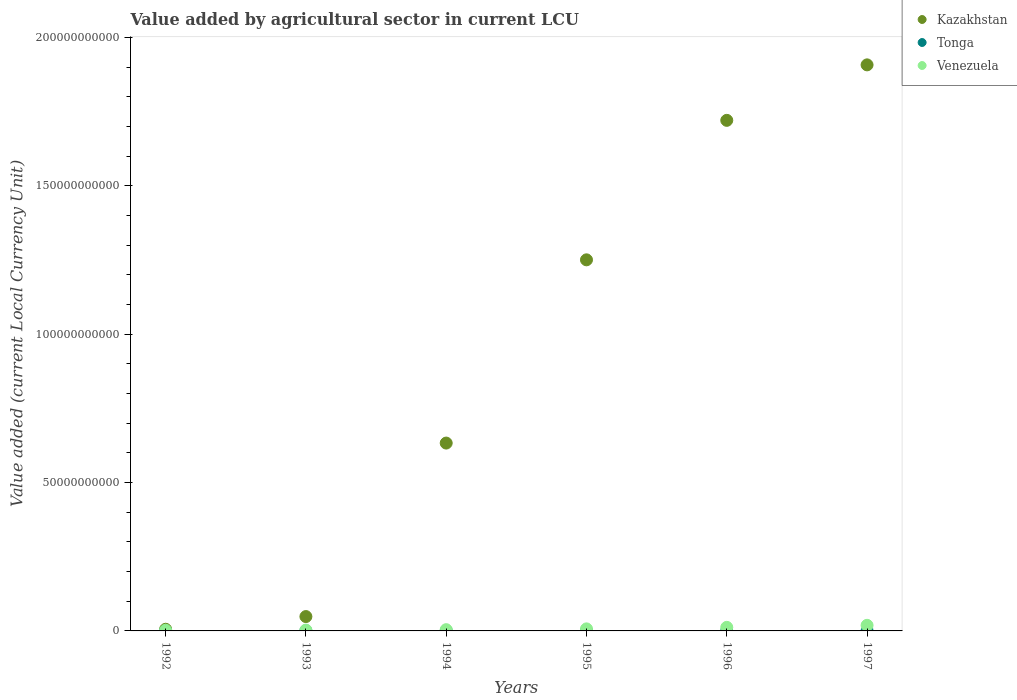How many different coloured dotlines are there?
Keep it short and to the point. 3. What is the value added by agricultural sector in Kazakhstan in 1992?
Your response must be concise. 5.63e+08. Across all years, what is the maximum value added by agricultural sector in Tonga?
Offer a very short reply. 6.54e+07. Across all years, what is the minimum value added by agricultural sector in Venezuela?
Provide a short and direct response. 2.12e+08. In which year was the value added by agricultural sector in Tonga minimum?
Keep it short and to the point. 1997. What is the total value added by agricultural sector in Venezuela in the graph?
Offer a terse response. 4.70e+09. What is the difference between the value added by agricultural sector in Kazakhstan in 1996 and that in 1997?
Make the answer very short. -1.87e+1. What is the difference between the value added by agricultural sector in Kazakhstan in 1993 and the value added by agricultural sector in Venezuela in 1997?
Offer a very short reply. 2.95e+09. What is the average value added by agricultural sector in Venezuela per year?
Provide a succinct answer. 7.83e+08. In the year 1995, what is the difference between the value added by agricultural sector in Tonga and value added by agricultural sector in Kazakhstan?
Make the answer very short. -1.25e+11. In how many years, is the value added by agricultural sector in Tonga greater than 190000000000 LCU?
Your response must be concise. 0. What is the ratio of the value added by agricultural sector in Venezuela in 1992 to that in 1993?
Your response must be concise. 0.75. Is the value added by agricultural sector in Kazakhstan in 1995 less than that in 1996?
Your answer should be very brief. Yes. Is the difference between the value added by agricultural sector in Tonga in 1992 and 1995 greater than the difference between the value added by agricultural sector in Kazakhstan in 1992 and 1995?
Your response must be concise. Yes. What is the difference between the highest and the second highest value added by agricultural sector in Kazakhstan?
Your response must be concise. 1.87e+1. What is the difference between the highest and the lowest value added by agricultural sector in Tonga?
Offer a very short reply. 1.03e+07. Does the value added by agricultural sector in Tonga monotonically increase over the years?
Give a very brief answer. No. Is the value added by agricultural sector in Tonga strictly greater than the value added by agricultural sector in Kazakhstan over the years?
Provide a short and direct response. No. Is the value added by agricultural sector in Venezuela strictly less than the value added by agricultural sector in Kazakhstan over the years?
Your answer should be compact. Yes. How many dotlines are there?
Provide a short and direct response. 3. What is the difference between two consecutive major ticks on the Y-axis?
Your answer should be very brief. 5.00e+1. Are the values on the major ticks of Y-axis written in scientific E-notation?
Make the answer very short. No. Does the graph contain grids?
Make the answer very short. No. Where does the legend appear in the graph?
Offer a terse response. Top right. How many legend labels are there?
Provide a short and direct response. 3. What is the title of the graph?
Ensure brevity in your answer.  Value added by agricultural sector in current LCU. Does "Bhutan" appear as one of the legend labels in the graph?
Ensure brevity in your answer.  No. What is the label or title of the Y-axis?
Ensure brevity in your answer.  Value added (current Local Currency Unit). What is the Value added (current Local Currency Unit) in Kazakhstan in 1992?
Make the answer very short. 5.63e+08. What is the Value added (current Local Currency Unit) in Tonga in 1992?
Your response must be concise. 6.05e+07. What is the Value added (current Local Currency Unit) in Venezuela in 1992?
Your answer should be compact. 2.12e+08. What is the Value added (current Local Currency Unit) in Kazakhstan in 1993?
Your response must be concise. 4.84e+09. What is the Value added (current Local Currency Unit) in Tonga in 1993?
Your response must be concise. 6.54e+07. What is the Value added (current Local Currency Unit) of Venezuela in 1993?
Your answer should be very brief. 2.82e+08. What is the Value added (current Local Currency Unit) of Kazakhstan in 1994?
Provide a short and direct response. 6.33e+1. What is the Value added (current Local Currency Unit) in Tonga in 1994?
Offer a terse response. 5.59e+07. What is the Value added (current Local Currency Unit) in Venezuela in 1994?
Your answer should be very brief. 4.23e+08. What is the Value added (current Local Currency Unit) in Kazakhstan in 1995?
Your answer should be compact. 1.25e+11. What is the Value added (current Local Currency Unit) in Tonga in 1995?
Offer a terse response. 5.51e+07. What is the Value added (current Local Currency Unit) in Venezuela in 1995?
Your answer should be very brief. 6.90e+08. What is the Value added (current Local Currency Unit) of Kazakhstan in 1996?
Provide a short and direct response. 1.72e+11. What is the Value added (current Local Currency Unit) of Tonga in 1996?
Your answer should be very brief. 5.58e+07. What is the Value added (current Local Currency Unit) of Venezuela in 1996?
Offer a very short reply. 1.20e+09. What is the Value added (current Local Currency Unit) of Kazakhstan in 1997?
Offer a very short reply. 1.91e+11. What is the Value added (current Local Currency Unit) in Tonga in 1997?
Offer a terse response. 5.50e+07. What is the Value added (current Local Currency Unit) of Venezuela in 1997?
Your answer should be very brief. 1.89e+09. Across all years, what is the maximum Value added (current Local Currency Unit) in Kazakhstan?
Provide a succinct answer. 1.91e+11. Across all years, what is the maximum Value added (current Local Currency Unit) in Tonga?
Provide a short and direct response. 6.54e+07. Across all years, what is the maximum Value added (current Local Currency Unit) of Venezuela?
Make the answer very short. 1.89e+09. Across all years, what is the minimum Value added (current Local Currency Unit) of Kazakhstan?
Your answer should be compact. 5.63e+08. Across all years, what is the minimum Value added (current Local Currency Unit) in Tonga?
Your response must be concise. 5.50e+07. Across all years, what is the minimum Value added (current Local Currency Unit) in Venezuela?
Offer a terse response. 2.12e+08. What is the total Value added (current Local Currency Unit) of Kazakhstan in the graph?
Make the answer very short. 5.57e+11. What is the total Value added (current Local Currency Unit) in Tonga in the graph?
Ensure brevity in your answer.  3.48e+08. What is the total Value added (current Local Currency Unit) of Venezuela in the graph?
Ensure brevity in your answer.  4.70e+09. What is the difference between the Value added (current Local Currency Unit) in Kazakhstan in 1992 and that in 1993?
Offer a terse response. -4.27e+09. What is the difference between the Value added (current Local Currency Unit) of Tonga in 1992 and that in 1993?
Offer a very short reply. -4.84e+06. What is the difference between the Value added (current Local Currency Unit) of Venezuela in 1992 and that in 1993?
Your answer should be compact. -7.00e+07. What is the difference between the Value added (current Local Currency Unit) of Kazakhstan in 1992 and that in 1994?
Ensure brevity in your answer.  -6.27e+1. What is the difference between the Value added (current Local Currency Unit) of Tonga in 1992 and that in 1994?
Your answer should be very brief. 4.68e+06. What is the difference between the Value added (current Local Currency Unit) of Venezuela in 1992 and that in 1994?
Provide a succinct answer. -2.11e+08. What is the difference between the Value added (current Local Currency Unit) of Kazakhstan in 1992 and that in 1995?
Provide a succinct answer. -1.24e+11. What is the difference between the Value added (current Local Currency Unit) in Tonga in 1992 and that in 1995?
Your response must be concise. 5.42e+06. What is the difference between the Value added (current Local Currency Unit) of Venezuela in 1992 and that in 1995?
Your answer should be very brief. -4.78e+08. What is the difference between the Value added (current Local Currency Unit) in Kazakhstan in 1992 and that in 1996?
Provide a succinct answer. -1.71e+11. What is the difference between the Value added (current Local Currency Unit) of Tonga in 1992 and that in 1996?
Offer a very short reply. 4.79e+06. What is the difference between the Value added (current Local Currency Unit) in Venezuela in 1992 and that in 1996?
Give a very brief answer. -9.92e+08. What is the difference between the Value added (current Local Currency Unit) of Kazakhstan in 1992 and that in 1997?
Provide a succinct answer. -1.90e+11. What is the difference between the Value added (current Local Currency Unit) in Tonga in 1992 and that in 1997?
Provide a succinct answer. 5.50e+06. What is the difference between the Value added (current Local Currency Unit) in Venezuela in 1992 and that in 1997?
Your answer should be compact. -1.67e+09. What is the difference between the Value added (current Local Currency Unit) in Kazakhstan in 1993 and that in 1994?
Your answer should be very brief. -5.85e+1. What is the difference between the Value added (current Local Currency Unit) of Tonga in 1993 and that in 1994?
Give a very brief answer. 9.52e+06. What is the difference between the Value added (current Local Currency Unit) of Venezuela in 1993 and that in 1994?
Offer a very short reply. -1.41e+08. What is the difference between the Value added (current Local Currency Unit) in Kazakhstan in 1993 and that in 1995?
Make the answer very short. -1.20e+11. What is the difference between the Value added (current Local Currency Unit) in Tonga in 1993 and that in 1995?
Make the answer very short. 1.03e+07. What is the difference between the Value added (current Local Currency Unit) in Venezuela in 1993 and that in 1995?
Provide a succinct answer. -4.08e+08. What is the difference between the Value added (current Local Currency Unit) of Kazakhstan in 1993 and that in 1996?
Your answer should be very brief. -1.67e+11. What is the difference between the Value added (current Local Currency Unit) of Tonga in 1993 and that in 1996?
Your response must be concise. 9.63e+06. What is the difference between the Value added (current Local Currency Unit) in Venezuela in 1993 and that in 1996?
Your answer should be compact. -9.22e+08. What is the difference between the Value added (current Local Currency Unit) in Kazakhstan in 1993 and that in 1997?
Your response must be concise. -1.86e+11. What is the difference between the Value added (current Local Currency Unit) of Tonga in 1993 and that in 1997?
Give a very brief answer. 1.03e+07. What is the difference between the Value added (current Local Currency Unit) of Venezuela in 1993 and that in 1997?
Give a very brief answer. -1.60e+09. What is the difference between the Value added (current Local Currency Unit) in Kazakhstan in 1994 and that in 1995?
Make the answer very short. -6.17e+1. What is the difference between the Value added (current Local Currency Unit) of Tonga in 1994 and that in 1995?
Your response must be concise. 7.38e+05. What is the difference between the Value added (current Local Currency Unit) of Venezuela in 1994 and that in 1995?
Ensure brevity in your answer.  -2.66e+08. What is the difference between the Value added (current Local Currency Unit) in Kazakhstan in 1994 and that in 1996?
Keep it short and to the point. -1.09e+11. What is the difference between the Value added (current Local Currency Unit) of Tonga in 1994 and that in 1996?
Provide a succinct answer. 1.06e+05. What is the difference between the Value added (current Local Currency Unit) in Venezuela in 1994 and that in 1996?
Offer a very short reply. -7.81e+08. What is the difference between the Value added (current Local Currency Unit) in Kazakhstan in 1994 and that in 1997?
Your answer should be very brief. -1.27e+11. What is the difference between the Value added (current Local Currency Unit) in Tonga in 1994 and that in 1997?
Provide a short and direct response. 8.18e+05. What is the difference between the Value added (current Local Currency Unit) of Venezuela in 1994 and that in 1997?
Provide a short and direct response. -1.46e+09. What is the difference between the Value added (current Local Currency Unit) in Kazakhstan in 1995 and that in 1996?
Provide a succinct answer. -4.70e+1. What is the difference between the Value added (current Local Currency Unit) in Tonga in 1995 and that in 1996?
Offer a very short reply. -6.32e+05. What is the difference between the Value added (current Local Currency Unit) of Venezuela in 1995 and that in 1996?
Your answer should be very brief. -5.14e+08. What is the difference between the Value added (current Local Currency Unit) in Kazakhstan in 1995 and that in 1997?
Offer a very short reply. -6.57e+1. What is the difference between the Value added (current Local Currency Unit) in Tonga in 1995 and that in 1997?
Make the answer very short. 8.03e+04. What is the difference between the Value added (current Local Currency Unit) in Venezuela in 1995 and that in 1997?
Make the answer very short. -1.20e+09. What is the difference between the Value added (current Local Currency Unit) in Kazakhstan in 1996 and that in 1997?
Offer a terse response. -1.87e+1. What is the difference between the Value added (current Local Currency Unit) of Tonga in 1996 and that in 1997?
Provide a short and direct response. 7.12e+05. What is the difference between the Value added (current Local Currency Unit) of Venezuela in 1996 and that in 1997?
Keep it short and to the point. -6.82e+08. What is the difference between the Value added (current Local Currency Unit) of Kazakhstan in 1992 and the Value added (current Local Currency Unit) of Tonga in 1993?
Ensure brevity in your answer.  4.98e+08. What is the difference between the Value added (current Local Currency Unit) of Kazakhstan in 1992 and the Value added (current Local Currency Unit) of Venezuela in 1993?
Your response must be concise. 2.81e+08. What is the difference between the Value added (current Local Currency Unit) of Tonga in 1992 and the Value added (current Local Currency Unit) of Venezuela in 1993?
Your answer should be very brief. -2.22e+08. What is the difference between the Value added (current Local Currency Unit) of Kazakhstan in 1992 and the Value added (current Local Currency Unit) of Tonga in 1994?
Offer a terse response. 5.07e+08. What is the difference between the Value added (current Local Currency Unit) in Kazakhstan in 1992 and the Value added (current Local Currency Unit) in Venezuela in 1994?
Provide a succinct answer. 1.40e+08. What is the difference between the Value added (current Local Currency Unit) in Tonga in 1992 and the Value added (current Local Currency Unit) in Venezuela in 1994?
Give a very brief answer. -3.63e+08. What is the difference between the Value added (current Local Currency Unit) of Kazakhstan in 1992 and the Value added (current Local Currency Unit) of Tonga in 1995?
Make the answer very short. 5.08e+08. What is the difference between the Value added (current Local Currency Unit) in Kazakhstan in 1992 and the Value added (current Local Currency Unit) in Venezuela in 1995?
Keep it short and to the point. -1.27e+08. What is the difference between the Value added (current Local Currency Unit) in Tonga in 1992 and the Value added (current Local Currency Unit) in Venezuela in 1995?
Give a very brief answer. -6.29e+08. What is the difference between the Value added (current Local Currency Unit) in Kazakhstan in 1992 and the Value added (current Local Currency Unit) in Tonga in 1996?
Your answer should be compact. 5.07e+08. What is the difference between the Value added (current Local Currency Unit) of Kazakhstan in 1992 and the Value added (current Local Currency Unit) of Venezuela in 1996?
Make the answer very short. -6.41e+08. What is the difference between the Value added (current Local Currency Unit) in Tonga in 1992 and the Value added (current Local Currency Unit) in Venezuela in 1996?
Provide a short and direct response. -1.14e+09. What is the difference between the Value added (current Local Currency Unit) of Kazakhstan in 1992 and the Value added (current Local Currency Unit) of Tonga in 1997?
Your answer should be compact. 5.08e+08. What is the difference between the Value added (current Local Currency Unit) of Kazakhstan in 1992 and the Value added (current Local Currency Unit) of Venezuela in 1997?
Your answer should be very brief. -1.32e+09. What is the difference between the Value added (current Local Currency Unit) of Tonga in 1992 and the Value added (current Local Currency Unit) of Venezuela in 1997?
Make the answer very short. -1.83e+09. What is the difference between the Value added (current Local Currency Unit) in Kazakhstan in 1993 and the Value added (current Local Currency Unit) in Tonga in 1994?
Give a very brief answer. 4.78e+09. What is the difference between the Value added (current Local Currency Unit) of Kazakhstan in 1993 and the Value added (current Local Currency Unit) of Venezuela in 1994?
Your answer should be very brief. 4.41e+09. What is the difference between the Value added (current Local Currency Unit) of Tonga in 1993 and the Value added (current Local Currency Unit) of Venezuela in 1994?
Give a very brief answer. -3.58e+08. What is the difference between the Value added (current Local Currency Unit) in Kazakhstan in 1993 and the Value added (current Local Currency Unit) in Tonga in 1995?
Offer a terse response. 4.78e+09. What is the difference between the Value added (current Local Currency Unit) in Kazakhstan in 1993 and the Value added (current Local Currency Unit) in Venezuela in 1995?
Provide a succinct answer. 4.15e+09. What is the difference between the Value added (current Local Currency Unit) of Tonga in 1993 and the Value added (current Local Currency Unit) of Venezuela in 1995?
Your answer should be compact. -6.24e+08. What is the difference between the Value added (current Local Currency Unit) of Kazakhstan in 1993 and the Value added (current Local Currency Unit) of Tonga in 1996?
Give a very brief answer. 4.78e+09. What is the difference between the Value added (current Local Currency Unit) in Kazakhstan in 1993 and the Value added (current Local Currency Unit) in Venezuela in 1996?
Ensure brevity in your answer.  3.63e+09. What is the difference between the Value added (current Local Currency Unit) of Tonga in 1993 and the Value added (current Local Currency Unit) of Venezuela in 1996?
Give a very brief answer. -1.14e+09. What is the difference between the Value added (current Local Currency Unit) in Kazakhstan in 1993 and the Value added (current Local Currency Unit) in Tonga in 1997?
Make the answer very short. 4.78e+09. What is the difference between the Value added (current Local Currency Unit) of Kazakhstan in 1993 and the Value added (current Local Currency Unit) of Venezuela in 1997?
Give a very brief answer. 2.95e+09. What is the difference between the Value added (current Local Currency Unit) in Tonga in 1993 and the Value added (current Local Currency Unit) in Venezuela in 1997?
Offer a very short reply. -1.82e+09. What is the difference between the Value added (current Local Currency Unit) of Kazakhstan in 1994 and the Value added (current Local Currency Unit) of Tonga in 1995?
Your answer should be very brief. 6.32e+1. What is the difference between the Value added (current Local Currency Unit) in Kazakhstan in 1994 and the Value added (current Local Currency Unit) in Venezuela in 1995?
Ensure brevity in your answer.  6.26e+1. What is the difference between the Value added (current Local Currency Unit) in Tonga in 1994 and the Value added (current Local Currency Unit) in Venezuela in 1995?
Provide a succinct answer. -6.34e+08. What is the difference between the Value added (current Local Currency Unit) in Kazakhstan in 1994 and the Value added (current Local Currency Unit) in Tonga in 1996?
Offer a very short reply. 6.32e+1. What is the difference between the Value added (current Local Currency Unit) of Kazakhstan in 1994 and the Value added (current Local Currency Unit) of Venezuela in 1996?
Make the answer very short. 6.21e+1. What is the difference between the Value added (current Local Currency Unit) in Tonga in 1994 and the Value added (current Local Currency Unit) in Venezuela in 1996?
Offer a terse response. -1.15e+09. What is the difference between the Value added (current Local Currency Unit) of Kazakhstan in 1994 and the Value added (current Local Currency Unit) of Tonga in 1997?
Your answer should be compact. 6.32e+1. What is the difference between the Value added (current Local Currency Unit) of Kazakhstan in 1994 and the Value added (current Local Currency Unit) of Venezuela in 1997?
Your answer should be very brief. 6.14e+1. What is the difference between the Value added (current Local Currency Unit) of Tonga in 1994 and the Value added (current Local Currency Unit) of Venezuela in 1997?
Offer a very short reply. -1.83e+09. What is the difference between the Value added (current Local Currency Unit) of Kazakhstan in 1995 and the Value added (current Local Currency Unit) of Tonga in 1996?
Keep it short and to the point. 1.25e+11. What is the difference between the Value added (current Local Currency Unit) in Kazakhstan in 1995 and the Value added (current Local Currency Unit) in Venezuela in 1996?
Your response must be concise. 1.24e+11. What is the difference between the Value added (current Local Currency Unit) of Tonga in 1995 and the Value added (current Local Currency Unit) of Venezuela in 1996?
Your answer should be very brief. -1.15e+09. What is the difference between the Value added (current Local Currency Unit) in Kazakhstan in 1995 and the Value added (current Local Currency Unit) in Tonga in 1997?
Offer a terse response. 1.25e+11. What is the difference between the Value added (current Local Currency Unit) in Kazakhstan in 1995 and the Value added (current Local Currency Unit) in Venezuela in 1997?
Ensure brevity in your answer.  1.23e+11. What is the difference between the Value added (current Local Currency Unit) of Tonga in 1995 and the Value added (current Local Currency Unit) of Venezuela in 1997?
Your response must be concise. -1.83e+09. What is the difference between the Value added (current Local Currency Unit) of Kazakhstan in 1996 and the Value added (current Local Currency Unit) of Tonga in 1997?
Offer a very short reply. 1.72e+11. What is the difference between the Value added (current Local Currency Unit) of Kazakhstan in 1996 and the Value added (current Local Currency Unit) of Venezuela in 1997?
Offer a very short reply. 1.70e+11. What is the difference between the Value added (current Local Currency Unit) of Tonga in 1996 and the Value added (current Local Currency Unit) of Venezuela in 1997?
Offer a very short reply. -1.83e+09. What is the average Value added (current Local Currency Unit) in Kazakhstan per year?
Provide a short and direct response. 9.28e+1. What is the average Value added (current Local Currency Unit) of Tonga per year?
Provide a succinct answer. 5.79e+07. What is the average Value added (current Local Currency Unit) of Venezuela per year?
Your answer should be very brief. 7.83e+08. In the year 1992, what is the difference between the Value added (current Local Currency Unit) of Kazakhstan and Value added (current Local Currency Unit) of Tonga?
Your response must be concise. 5.02e+08. In the year 1992, what is the difference between the Value added (current Local Currency Unit) in Kazakhstan and Value added (current Local Currency Unit) in Venezuela?
Give a very brief answer. 3.51e+08. In the year 1992, what is the difference between the Value added (current Local Currency Unit) of Tonga and Value added (current Local Currency Unit) of Venezuela?
Offer a terse response. -1.52e+08. In the year 1993, what is the difference between the Value added (current Local Currency Unit) of Kazakhstan and Value added (current Local Currency Unit) of Tonga?
Offer a terse response. 4.77e+09. In the year 1993, what is the difference between the Value added (current Local Currency Unit) of Kazakhstan and Value added (current Local Currency Unit) of Venezuela?
Your answer should be very brief. 4.55e+09. In the year 1993, what is the difference between the Value added (current Local Currency Unit) in Tonga and Value added (current Local Currency Unit) in Venezuela?
Offer a terse response. -2.17e+08. In the year 1994, what is the difference between the Value added (current Local Currency Unit) in Kazakhstan and Value added (current Local Currency Unit) in Tonga?
Make the answer very short. 6.32e+1. In the year 1994, what is the difference between the Value added (current Local Currency Unit) of Kazakhstan and Value added (current Local Currency Unit) of Venezuela?
Your response must be concise. 6.29e+1. In the year 1994, what is the difference between the Value added (current Local Currency Unit) in Tonga and Value added (current Local Currency Unit) in Venezuela?
Ensure brevity in your answer.  -3.67e+08. In the year 1995, what is the difference between the Value added (current Local Currency Unit) of Kazakhstan and Value added (current Local Currency Unit) of Tonga?
Offer a very short reply. 1.25e+11. In the year 1995, what is the difference between the Value added (current Local Currency Unit) of Kazakhstan and Value added (current Local Currency Unit) of Venezuela?
Make the answer very short. 1.24e+11. In the year 1995, what is the difference between the Value added (current Local Currency Unit) of Tonga and Value added (current Local Currency Unit) of Venezuela?
Make the answer very short. -6.35e+08. In the year 1996, what is the difference between the Value added (current Local Currency Unit) of Kazakhstan and Value added (current Local Currency Unit) of Tonga?
Your answer should be compact. 1.72e+11. In the year 1996, what is the difference between the Value added (current Local Currency Unit) in Kazakhstan and Value added (current Local Currency Unit) in Venezuela?
Offer a terse response. 1.71e+11. In the year 1996, what is the difference between the Value added (current Local Currency Unit) in Tonga and Value added (current Local Currency Unit) in Venezuela?
Offer a very short reply. -1.15e+09. In the year 1997, what is the difference between the Value added (current Local Currency Unit) of Kazakhstan and Value added (current Local Currency Unit) of Tonga?
Ensure brevity in your answer.  1.91e+11. In the year 1997, what is the difference between the Value added (current Local Currency Unit) in Kazakhstan and Value added (current Local Currency Unit) in Venezuela?
Make the answer very short. 1.89e+11. In the year 1997, what is the difference between the Value added (current Local Currency Unit) in Tonga and Value added (current Local Currency Unit) in Venezuela?
Offer a very short reply. -1.83e+09. What is the ratio of the Value added (current Local Currency Unit) in Kazakhstan in 1992 to that in 1993?
Offer a terse response. 0.12. What is the ratio of the Value added (current Local Currency Unit) of Tonga in 1992 to that in 1993?
Provide a short and direct response. 0.93. What is the ratio of the Value added (current Local Currency Unit) in Venezuela in 1992 to that in 1993?
Your response must be concise. 0.75. What is the ratio of the Value added (current Local Currency Unit) of Kazakhstan in 1992 to that in 1994?
Give a very brief answer. 0.01. What is the ratio of the Value added (current Local Currency Unit) in Tonga in 1992 to that in 1994?
Offer a terse response. 1.08. What is the ratio of the Value added (current Local Currency Unit) in Venezuela in 1992 to that in 1994?
Ensure brevity in your answer.  0.5. What is the ratio of the Value added (current Local Currency Unit) in Kazakhstan in 1992 to that in 1995?
Offer a very short reply. 0. What is the ratio of the Value added (current Local Currency Unit) of Tonga in 1992 to that in 1995?
Give a very brief answer. 1.1. What is the ratio of the Value added (current Local Currency Unit) in Venezuela in 1992 to that in 1995?
Offer a terse response. 0.31. What is the ratio of the Value added (current Local Currency Unit) of Kazakhstan in 1992 to that in 1996?
Your answer should be very brief. 0. What is the ratio of the Value added (current Local Currency Unit) of Tonga in 1992 to that in 1996?
Your answer should be very brief. 1.09. What is the ratio of the Value added (current Local Currency Unit) of Venezuela in 1992 to that in 1996?
Offer a terse response. 0.18. What is the ratio of the Value added (current Local Currency Unit) of Kazakhstan in 1992 to that in 1997?
Give a very brief answer. 0. What is the ratio of the Value added (current Local Currency Unit) of Tonga in 1992 to that in 1997?
Your answer should be compact. 1.1. What is the ratio of the Value added (current Local Currency Unit) of Venezuela in 1992 to that in 1997?
Your answer should be very brief. 0.11. What is the ratio of the Value added (current Local Currency Unit) of Kazakhstan in 1993 to that in 1994?
Offer a very short reply. 0.08. What is the ratio of the Value added (current Local Currency Unit) in Tonga in 1993 to that in 1994?
Offer a very short reply. 1.17. What is the ratio of the Value added (current Local Currency Unit) in Venezuela in 1993 to that in 1994?
Keep it short and to the point. 0.67. What is the ratio of the Value added (current Local Currency Unit) in Kazakhstan in 1993 to that in 1995?
Your answer should be very brief. 0.04. What is the ratio of the Value added (current Local Currency Unit) in Tonga in 1993 to that in 1995?
Give a very brief answer. 1.19. What is the ratio of the Value added (current Local Currency Unit) of Venezuela in 1993 to that in 1995?
Make the answer very short. 0.41. What is the ratio of the Value added (current Local Currency Unit) of Kazakhstan in 1993 to that in 1996?
Make the answer very short. 0.03. What is the ratio of the Value added (current Local Currency Unit) of Tonga in 1993 to that in 1996?
Offer a very short reply. 1.17. What is the ratio of the Value added (current Local Currency Unit) in Venezuela in 1993 to that in 1996?
Offer a very short reply. 0.23. What is the ratio of the Value added (current Local Currency Unit) in Kazakhstan in 1993 to that in 1997?
Provide a short and direct response. 0.03. What is the ratio of the Value added (current Local Currency Unit) of Tonga in 1993 to that in 1997?
Ensure brevity in your answer.  1.19. What is the ratio of the Value added (current Local Currency Unit) in Venezuela in 1993 to that in 1997?
Offer a terse response. 0.15. What is the ratio of the Value added (current Local Currency Unit) of Kazakhstan in 1994 to that in 1995?
Provide a short and direct response. 0.51. What is the ratio of the Value added (current Local Currency Unit) in Tonga in 1994 to that in 1995?
Make the answer very short. 1.01. What is the ratio of the Value added (current Local Currency Unit) in Venezuela in 1994 to that in 1995?
Make the answer very short. 0.61. What is the ratio of the Value added (current Local Currency Unit) of Kazakhstan in 1994 to that in 1996?
Offer a very short reply. 0.37. What is the ratio of the Value added (current Local Currency Unit) of Tonga in 1994 to that in 1996?
Your response must be concise. 1. What is the ratio of the Value added (current Local Currency Unit) in Venezuela in 1994 to that in 1996?
Your response must be concise. 0.35. What is the ratio of the Value added (current Local Currency Unit) in Kazakhstan in 1994 to that in 1997?
Offer a terse response. 0.33. What is the ratio of the Value added (current Local Currency Unit) in Tonga in 1994 to that in 1997?
Give a very brief answer. 1.01. What is the ratio of the Value added (current Local Currency Unit) of Venezuela in 1994 to that in 1997?
Keep it short and to the point. 0.22. What is the ratio of the Value added (current Local Currency Unit) of Kazakhstan in 1995 to that in 1996?
Your response must be concise. 0.73. What is the ratio of the Value added (current Local Currency Unit) in Tonga in 1995 to that in 1996?
Offer a very short reply. 0.99. What is the ratio of the Value added (current Local Currency Unit) of Venezuela in 1995 to that in 1996?
Make the answer very short. 0.57. What is the ratio of the Value added (current Local Currency Unit) of Kazakhstan in 1995 to that in 1997?
Offer a terse response. 0.66. What is the ratio of the Value added (current Local Currency Unit) of Tonga in 1995 to that in 1997?
Make the answer very short. 1. What is the ratio of the Value added (current Local Currency Unit) in Venezuela in 1995 to that in 1997?
Provide a short and direct response. 0.37. What is the ratio of the Value added (current Local Currency Unit) in Kazakhstan in 1996 to that in 1997?
Your response must be concise. 0.9. What is the ratio of the Value added (current Local Currency Unit) of Tonga in 1996 to that in 1997?
Your answer should be very brief. 1.01. What is the ratio of the Value added (current Local Currency Unit) of Venezuela in 1996 to that in 1997?
Provide a succinct answer. 0.64. What is the difference between the highest and the second highest Value added (current Local Currency Unit) of Kazakhstan?
Your answer should be very brief. 1.87e+1. What is the difference between the highest and the second highest Value added (current Local Currency Unit) of Tonga?
Ensure brevity in your answer.  4.84e+06. What is the difference between the highest and the second highest Value added (current Local Currency Unit) in Venezuela?
Make the answer very short. 6.82e+08. What is the difference between the highest and the lowest Value added (current Local Currency Unit) in Kazakhstan?
Your answer should be very brief. 1.90e+11. What is the difference between the highest and the lowest Value added (current Local Currency Unit) of Tonga?
Provide a short and direct response. 1.03e+07. What is the difference between the highest and the lowest Value added (current Local Currency Unit) of Venezuela?
Make the answer very short. 1.67e+09. 